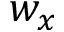<formula> <loc_0><loc_0><loc_500><loc_500>w _ { x }</formula> 